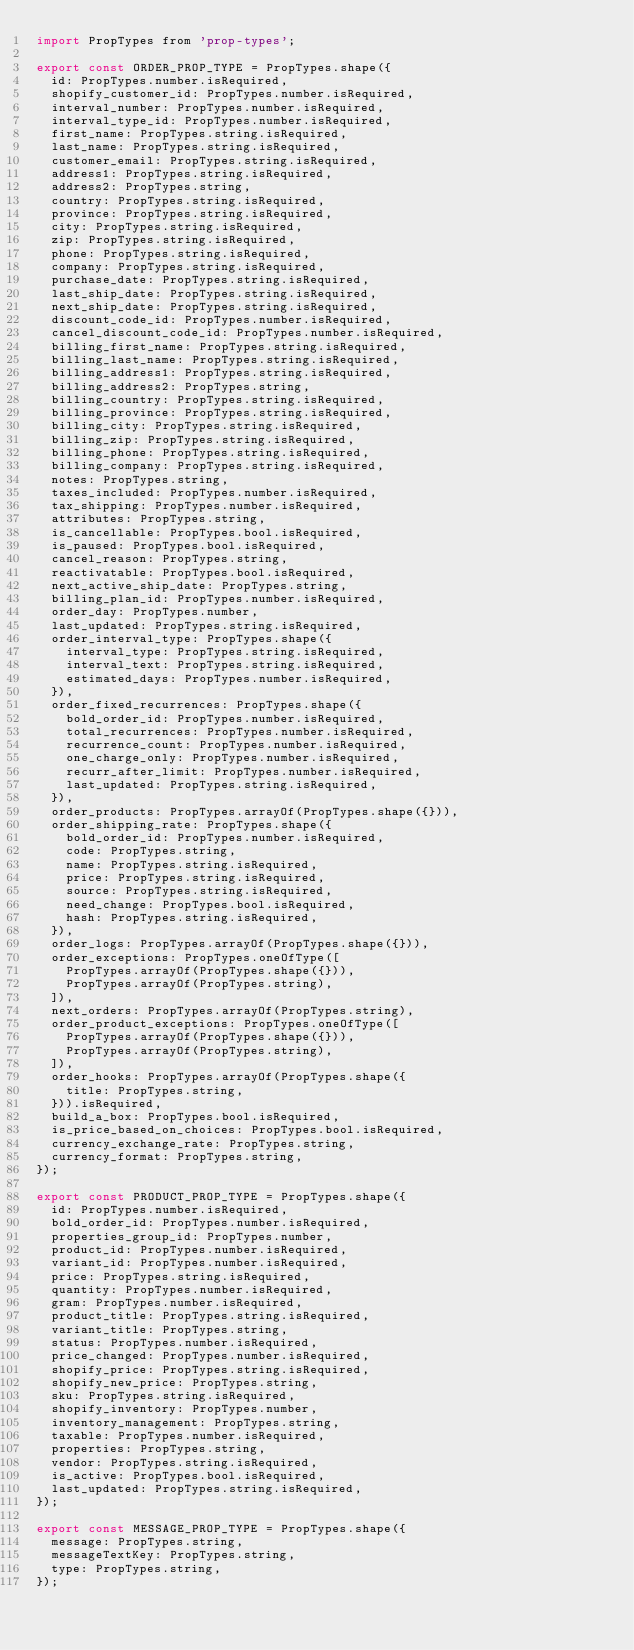<code> <loc_0><loc_0><loc_500><loc_500><_JavaScript_>import PropTypes from 'prop-types';

export const ORDER_PROP_TYPE = PropTypes.shape({
  id: PropTypes.number.isRequired,
  shopify_customer_id: PropTypes.number.isRequired,
  interval_number: PropTypes.number.isRequired,
  interval_type_id: PropTypes.number.isRequired,
  first_name: PropTypes.string.isRequired,
  last_name: PropTypes.string.isRequired,
  customer_email: PropTypes.string.isRequired,
  address1: PropTypes.string.isRequired,
  address2: PropTypes.string,
  country: PropTypes.string.isRequired,
  province: PropTypes.string.isRequired,
  city: PropTypes.string.isRequired,
  zip: PropTypes.string.isRequired,
  phone: PropTypes.string.isRequired,
  company: PropTypes.string.isRequired,
  purchase_date: PropTypes.string.isRequired,
  last_ship_date: PropTypes.string.isRequired,
  next_ship_date: PropTypes.string.isRequired,
  discount_code_id: PropTypes.number.isRequired,
  cancel_discount_code_id: PropTypes.number.isRequired,
  billing_first_name: PropTypes.string.isRequired,
  billing_last_name: PropTypes.string.isRequired,
  billing_address1: PropTypes.string.isRequired,
  billing_address2: PropTypes.string,
  billing_country: PropTypes.string.isRequired,
  billing_province: PropTypes.string.isRequired,
  billing_city: PropTypes.string.isRequired,
  billing_zip: PropTypes.string.isRequired,
  billing_phone: PropTypes.string.isRequired,
  billing_company: PropTypes.string.isRequired,
  notes: PropTypes.string,
  taxes_included: PropTypes.number.isRequired,
  tax_shipping: PropTypes.number.isRequired,
  attributes: PropTypes.string,
  is_cancellable: PropTypes.bool.isRequired,
  is_paused: PropTypes.bool.isRequired,
  cancel_reason: PropTypes.string,
  reactivatable: PropTypes.bool.isRequired,
  next_active_ship_date: PropTypes.string,
  billing_plan_id: PropTypes.number.isRequired,
  order_day: PropTypes.number,
  last_updated: PropTypes.string.isRequired,
  order_interval_type: PropTypes.shape({
    interval_type: PropTypes.string.isRequired,
    interval_text: PropTypes.string.isRequired,
    estimated_days: PropTypes.number.isRequired,
  }),
  order_fixed_recurrences: PropTypes.shape({
    bold_order_id: PropTypes.number.isRequired,
    total_recurrences: PropTypes.number.isRequired,
    recurrence_count: PropTypes.number.isRequired,
    one_charge_only: PropTypes.number.isRequired,
    recurr_after_limit: PropTypes.number.isRequired,
    last_updated: PropTypes.string.isRequired,
  }),
  order_products: PropTypes.arrayOf(PropTypes.shape({})),
  order_shipping_rate: PropTypes.shape({
    bold_order_id: PropTypes.number.isRequired,
    code: PropTypes.string,
    name: PropTypes.string.isRequired,
    price: PropTypes.string.isRequired,
    source: PropTypes.string.isRequired,
    need_change: PropTypes.bool.isRequired,
    hash: PropTypes.string.isRequired,
  }),
  order_logs: PropTypes.arrayOf(PropTypes.shape({})),
  order_exceptions: PropTypes.oneOfType([
    PropTypes.arrayOf(PropTypes.shape({})),
    PropTypes.arrayOf(PropTypes.string),
  ]),
  next_orders: PropTypes.arrayOf(PropTypes.string),
  order_product_exceptions: PropTypes.oneOfType([
    PropTypes.arrayOf(PropTypes.shape({})),
    PropTypes.arrayOf(PropTypes.string),
  ]),
  order_hooks: PropTypes.arrayOf(PropTypes.shape({
    title: PropTypes.string,
  })).isRequired,
  build_a_box: PropTypes.bool.isRequired,
  is_price_based_on_choices: PropTypes.bool.isRequired,
  currency_exchange_rate: PropTypes.string,
  currency_format: PropTypes.string,
});

export const PRODUCT_PROP_TYPE = PropTypes.shape({
  id: PropTypes.number.isRequired,
  bold_order_id: PropTypes.number.isRequired,
  properties_group_id: PropTypes.number,
  product_id: PropTypes.number.isRequired,
  variant_id: PropTypes.number.isRequired,
  price: PropTypes.string.isRequired,
  quantity: PropTypes.number.isRequired,
  gram: PropTypes.number.isRequired,
  product_title: PropTypes.string.isRequired,
  variant_title: PropTypes.string,
  status: PropTypes.number.isRequired,
  price_changed: PropTypes.number.isRequired,
  shopify_price: PropTypes.string.isRequired,
  shopify_new_price: PropTypes.string,
  sku: PropTypes.string.isRequired,
  shopify_inventory: PropTypes.number,
  inventory_management: PropTypes.string,
  taxable: PropTypes.number.isRequired,
  properties: PropTypes.string,
  vendor: PropTypes.string.isRequired,
  is_active: PropTypes.bool.isRequired,
  last_updated: PropTypes.string.isRequired,
});

export const MESSAGE_PROP_TYPE = PropTypes.shape({
  message: PropTypes.string,
  messageTextKey: PropTypes.string,
  type: PropTypes.string,
});
</code> 